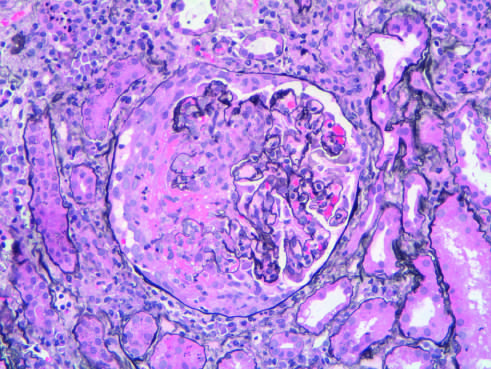does normal media for comparison indicate areas of necrosis and crescent formation?
Answer the question using a single word or phrase. No 